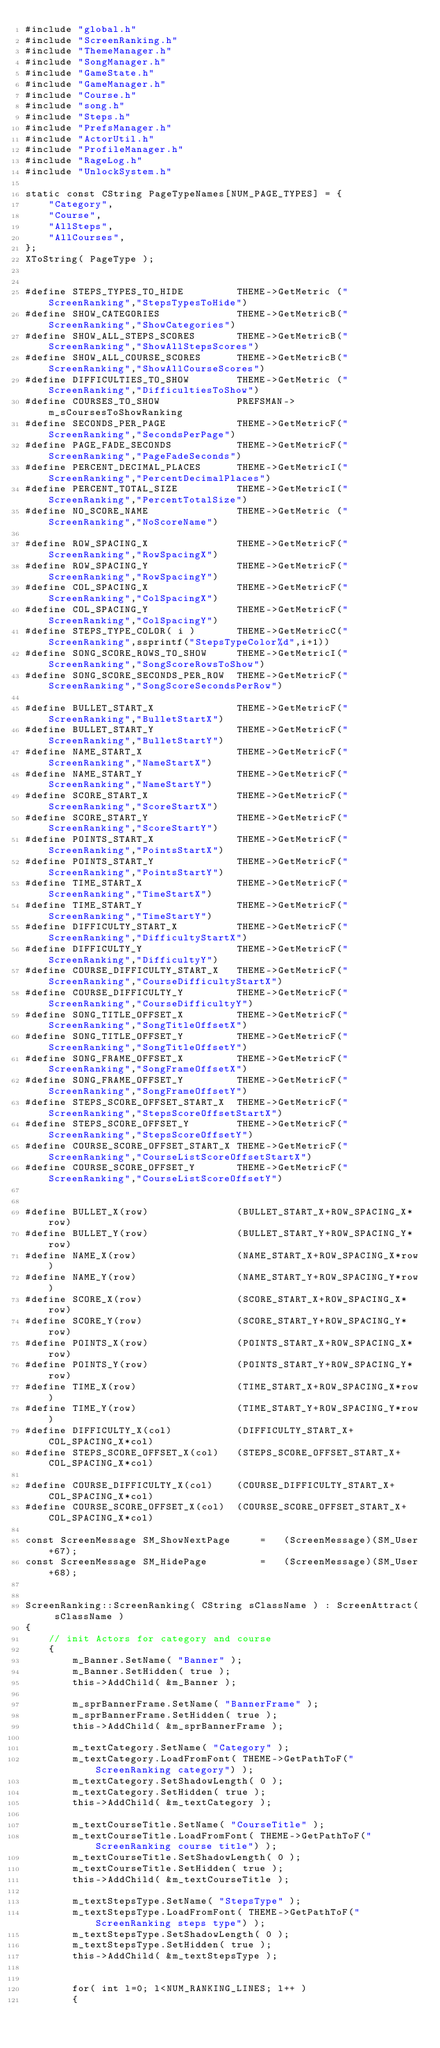<code> <loc_0><loc_0><loc_500><loc_500><_C++_>#include "global.h"
#include "ScreenRanking.h"
#include "ThemeManager.h"
#include "SongManager.h"
#include "GameState.h"
#include "GameManager.h"
#include "Course.h"
#include "song.h"
#include "Steps.h"
#include "PrefsManager.h"
#include "ActorUtil.h"
#include "ProfileManager.h"
#include "RageLog.h"
#include "UnlockSystem.h"

static const CString PageTypeNames[NUM_PAGE_TYPES] = {
	"Category",
	"Course",
	"AllSteps",
	"AllCourses",
};
XToString( PageType );


#define STEPS_TYPES_TO_HIDE			THEME->GetMetric ("ScreenRanking","StepsTypesToHide")
#define SHOW_CATEGORIES				THEME->GetMetricB("ScreenRanking","ShowCategories")
#define SHOW_ALL_STEPS_SCORES		THEME->GetMetricB("ScreenRanking","ShowAllStepsScores")
#define SHOW_ALL_COURSE_SCORES		THEME->GetMetricB("ScreenRanking","ShowAllCourseScores")
#define DIFFICULTIES_TO_SHOW		THEME->GetMetric ("ScreenRanking","DifficultiesToShow")
#define COURSES_TO_SHOW				PREFSMAN->m_sCoursesToShowRanking
#define SECONDS_PER_PAGE			THEME->GetMetricF("ScreenRanking","SecondsPerPage")
#define PAGE_FADE_SECONDS			THEME->GetMetricF("ScreenRanking","PageFadeSeconds")
#define PERCENT_DECIMAL_PLACES		THEME->GetMetricI("ScreenRanking","PercentDecimalPlaces")
#define PERCENT_TOTAL_SIZE			THEME->GetMetricI("ScreenRanking","PercentTotalSize")
#define NO_SCORE_NAME				THEME->GetMetric ("ScreenRanking","NoScoreName")

#define ROW_SPACING_X				THEME->GetMetricF("ScreenRanking","RowSpacingX")
#define ROW_SPACING_Y				THEME->GetMetricF("ScreenRanking","RowSpacingY")
#define COL_SPACING_X				THEME->GetMetricF("ScreenRanking","ColSpacingX")
#define COL_SPACING_Y				THEME->GetMetricF("ScreenRanking","ColSpacingY")
#define STEPS_TYPE_COLOR( i )		THEME->GetMetricC("ScreenRanking",ssprintf("StepsTypeColor%d",i+1))
#define SONG_SCORE_ROWS_TO_SHOW		THEME->GetMetricI("ScreenRanking","SongScoreRowsToShow")
#define SONG_SCORE_SECONDS_PER_ROW	THEME->GetMetricF("ScreenRanking","SongScoreSecondsPerRow")

#define BULLET_START_X				THEME->GetMetricF("ScreenRanking","BulletStartX")
#define BULLET_START_Y				THEME->GetMetricF("ScreenRanking","BulletStartY")
#define NAME_START_X				THEME->GetMetricF("ScreenRanking","NameStartX")
#define NAME_START_Y				THEME->GetMetricF("ScreenRanking","NameStartY")
#define SCORE_START_X				THEME->GetMetricF("ScreenRanking","ScoreStartX")
#define SCORE_START_Y				THEME->GetMetricF("ScreenRanking","ScoreStartY")
#define POINTS_START_X				THEME->GetMetricF("ScreenRanking","PointsStartX")
#define POINTS_START_Y				THEME->GetMetricF("ScreenRanking","PointsStartY")
#define TIME_START_X				THEME->GetMetricF("ScreenRanking","TimeStartX")
#define TIME_START_Y				THEME->GetMetricF("ScreenRanking","TimeStartY")
#define DIFFICULTY_START_X			THEME->GetMetricF("ScreenRanking","DifficultyStartX")
#define DIFFICULTY_Y				THEME->GetMetricF("ScreenRanking","DifficultyY")
#define COURSE_DIFFICULTY_START_X	THEME->GetMetricF("ScreenRanking","CourseDifficultyStartX")
#define COURSE_DIFFICULTY_Y			THEME->GetMetricF("ScreenRanking","CourseDifficultyY")
#define SONG_TITLE_OFFSET_X			THEME->GetMetricF("ScreenRanking","SongTitleOffsetX")
#define SONG_TITLE_OFFSET_Y			THEME->GetMetricF("ScreenRanking","SongTitleOffsetY")
#define SONG_FRAME_OFFSET_X			THEME->GetMetricF("ScreenRanking","SongFrameOffsetX")
#define SONG_FRAME_OFFSET_Y			THEME->GetMetricF("ScreenRanking","SongFrameOffsetY")
#define STEPS_SCORE_OFFSET_START_X	THEME->GetMetricF("ScreenRanking","StepsScoreOffsetStartX")
#define STEPS_SCORE_OFFSET_Y		THEME->GetMetricF("ScreenRanking","StepsScoreOffsetY")
#define COURSE_SCORE_OFFSET_START_X	THEME->GetMetricF("ScreenRanking","CourseListScoreOffsetStartX")
#define COURSE_SCORE_OFFSET_Y		THEME->GetMetricF("ScreenRanking","CourseListScoreOffsetY")


#define BULLET_X(row)				(BULLET_START_X+ROW_SPACING_X*row)
#define BULLET_Y(row)				(BULLET_START_Y+ROW_SPACING_Y*row)
#define NAME_X(row)					(NAME_START_X+ROW_SPACING_X*row)
#define NAME_Y(row)					(NAME_START_Y+ROW_SPACING_Y*row)
#define SCORE_X(row)				(SCORE_START_X+ROW_SPACING_X*row)
#define SCORE_Y(row)				(SCORE_START_Y+ROW_SPACING_Y*row)
#define POINTS_X(row)				(POINTS_START_X+ROW_SPACING_X*row)
#define POINTS_Y(row)				(POINTS_START_Y+ROW_SPACING_Y*row)
#define TIME_X(row)					(TIME_START_X+ROW_SPACING_X*row)
#define TIME_Y(row)					(TIME_START_Y+ROW_SPACING_Y*row)
#define DIFFICULTY_X(col)			(DIFFICULTY_START_X+COL_SPACING_X*col)
#define STEPS_SCORE_OFFSET_X(col)	(STEPS_SCORE_OFFSET_START_X+COL_SPACING_X*col)

#define COURSE_DIFFICULTY_X(col)	(COURSE_DIFFICULTY_START_X+COL_SPACING_X*col)
#define COURSE_SCORE_OFFSET_X(col)	(COURSE_SCORE_OFFSET_START_X+COL_SPACING_X*col)

const ScreenMessage SM_ShowNextPage		=	(ScreenMessage)(SM_User+67);
const ScreenMessage SM_HidePage			=	(ScreenMessage)(SM_User+68);


ScreenRanking::ScreenRanking( CString sClassName ) : ScreenAttract( sClassName )
{
	// init Actors for category and course
	{
		m_Banner.SetName( "Banner" );
		m_Banner.SetHidden( true );
		this->AddChild( &m_Banner );

		m_sprBannerFrame.SetName( "BannerFrame" );
		m_sprBannerFrame.SetHidden( true );
		this->AddChild( &m_sprBannerFrame );

		m_textCategory.SetName( "Category" );
		m_textCategory.LoadFromFont( THEME->GetPathToF("ScreenRanking category") );
		m_textCategory.SetShadowLength( 0 );
		m_textCategory.SetHidden( true );
		this->AddChild( &m_textCategory );

		m_textCourseTitle.SetName( "CourseTitle" );
		m_textCourseTitle.LoadFromFont( THEME->GetPathToF("ScreenRanking course title") );
		m_textCourseTitle.SetShadowLength( 0 );
		m_textCourseTitle.SetHidden( true );
		this->AddChild( &m_textCourseTitle );

		m_textStepsType.SetName( "StepsType" );
		m_textStepsType.LoadFromFont( THEME->GetPathToF("ScreenRanking steps type") );
		m_textStepsType.SetShadowLength( 0 );
		m_textStepsType.SetHidden( true );
		this->AddChild( &m_textStepsType );


		for( int l=0; l<NUM_RANKING_LINES; l++ )
		{</code> 